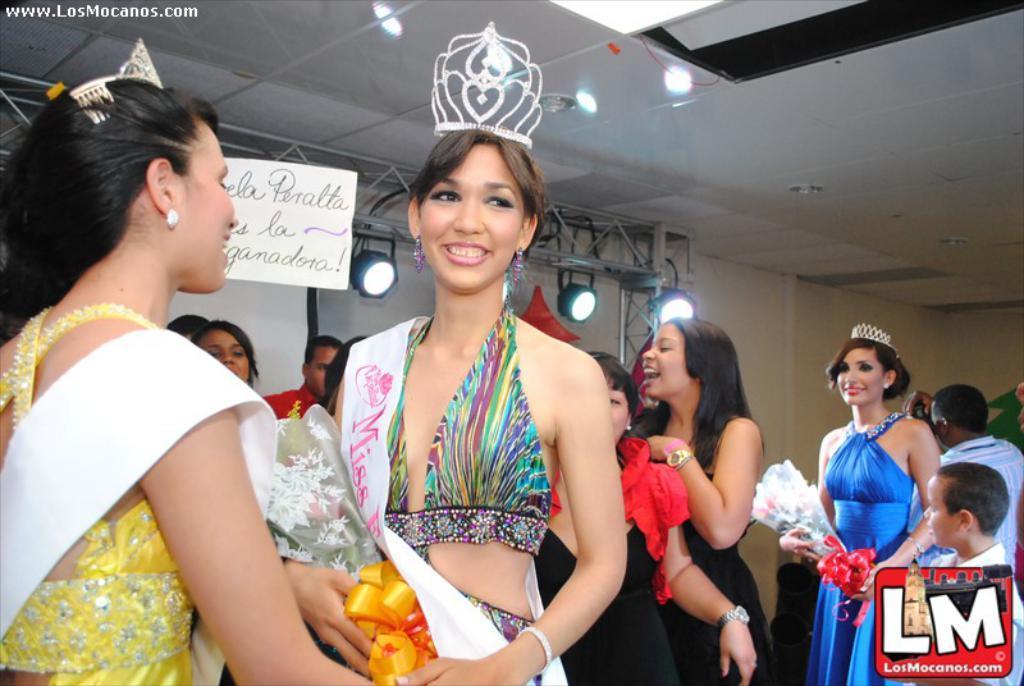Describe this image in one or two sentences. At the top we can see the ceiling. In the background we can see the wall, beam rods and lights. In this picture we can see people standing. We can see few women wore crowns and holding bouquets in their hands and smiling. At the bottom and top portion of the picture we can see the watermarks. 